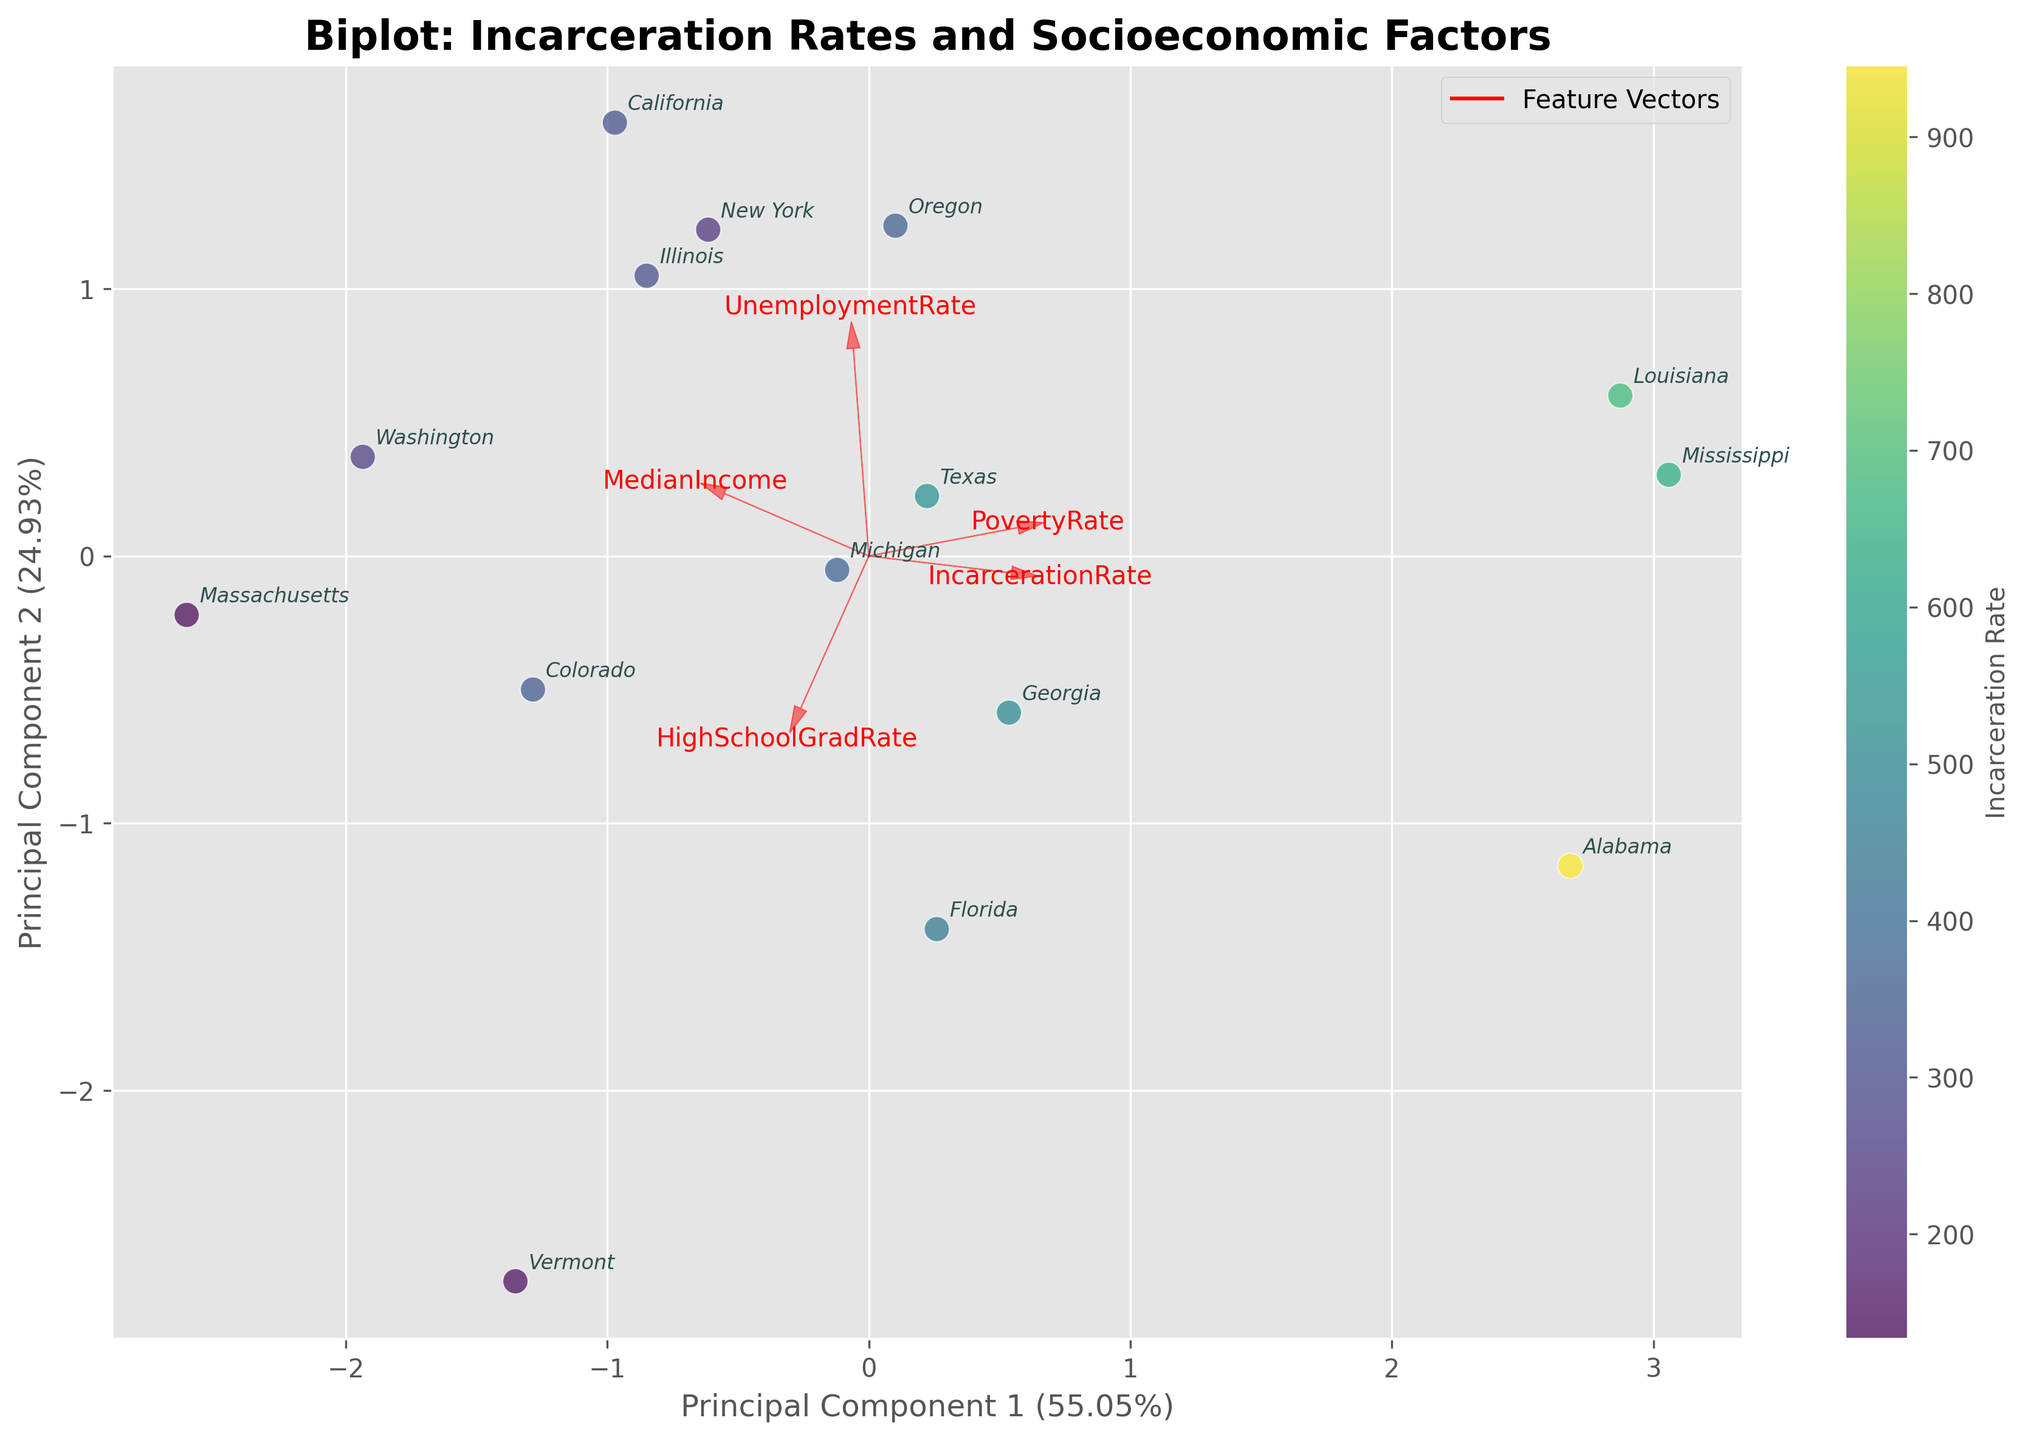Which state has the highest incarceration rate? To determine the state with the highest incarceration rate, find the state label closest to the color representing the highest value on the colorbar. Here, it is Louisiana.
Answer: Louisiana What socioeconomic factor has the strongest negative relationship with incarceration rate according to the feature vectors? Look at the direction of the feature vectors. The vector for MedianIncome points in nearly the opposite direction to the incarceration data points, which indicates a strong negative relationship.
Answer: MedianIncome Is there a noticeable pattern between high school graduation rates and incarceration rates? Observe the orientation of the feature vectors. The HighSchoolGradRate vector is pointing in the opposite direction of the cluster of incarceration rates, suggesting an inverse relationship.
Answer: Yes, inverse Which principal component explains more variance in the data, and what is its contribution? Check the axis labels for the principal components. The x-axis (Principal Component 1) explains more variance. The label indicates the percentage of variance explained.
Answer: Principal Component 1, 57.62% Which states are most similar in terms of their socioeconomic factors and incarceration rates, according to the biplot? Compare the positions of state labels in the biplot. New York and Washington are close to each other, indicating similarity in their combined socioeconomic factors and incarceration rates.
Answer: New York and Washington Is there any state with both low incarceration and low poverty rates? Identify states located in the lower sections of the color gradient (low incarceration rates) and look for those near the PovertyRate feature vector pointing in the opposite direction. Massachusetts and Vermont fit this criterion.
Answer: Massachusetts and Vermont Based on the biplot, which socioeconomic factor is least associated with the variance in the incarceration rates? The shortest feature vector suggests the least influence on variance. HighSchoolGradRate seems to be shorter compared to others.
Answer: HighSchoolGradRate 